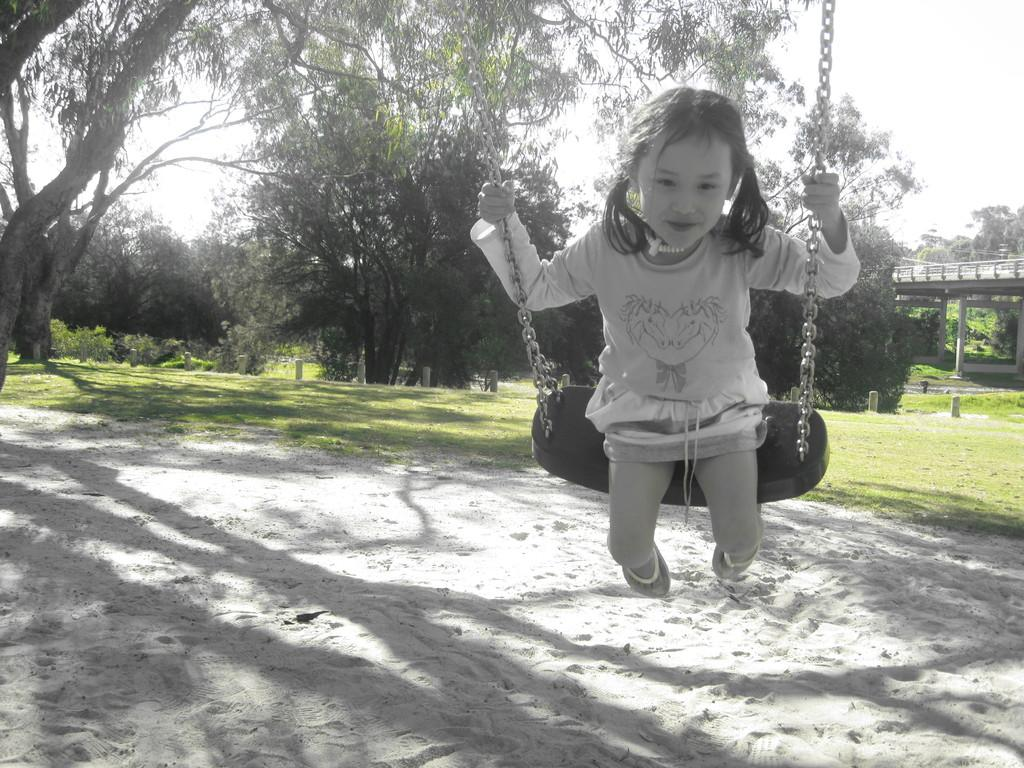Who is the main subject in the image? There is a girl in the image. What is the girl doing in the image? The girl is sitting on a tire swing. What can be seen in the background of the image? There are trees, sky, and poles visible in the background of the image. How many apples are hanging from the scarecrow in the image? There is no scarecrow or apples present in the image. What effect does the girl's presence have on the tire swing in the image? The image does not show any effect on the tire swing due to the girl's presence; it simply shows her sitting on it. 